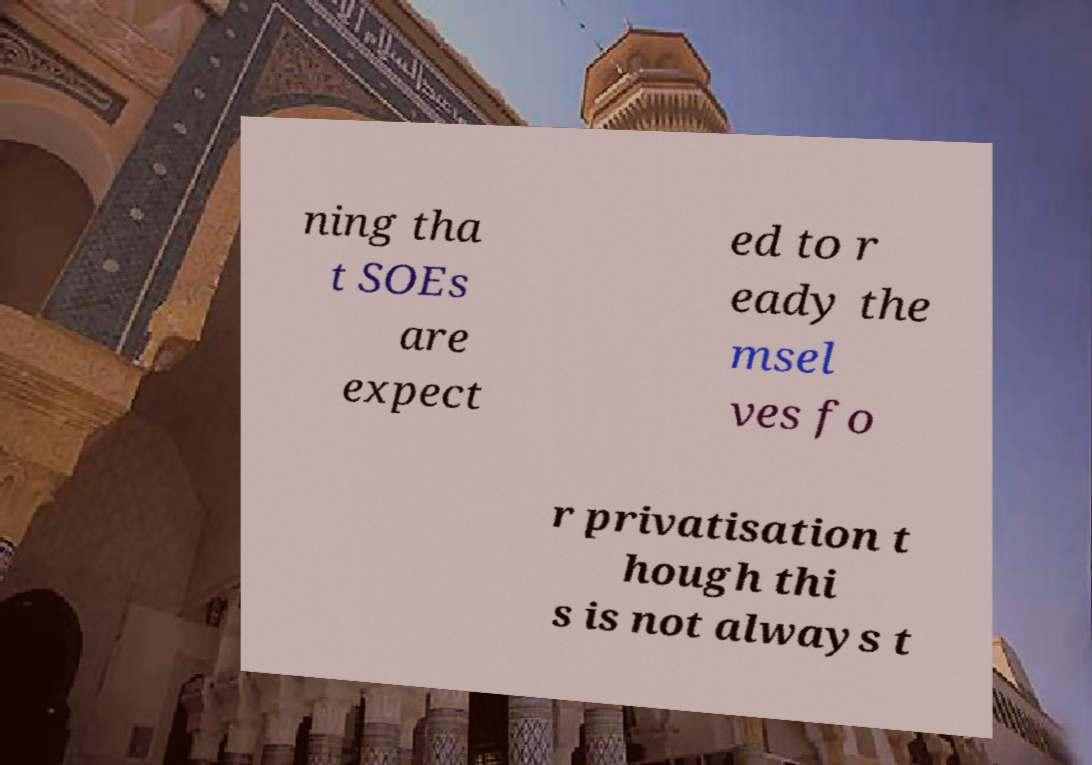Can you accurately transcribe the text from the provided image for me? ning tha t SOEs are expect ed to r eady the msel ves fo r privatisation t hough thi s is not always t 